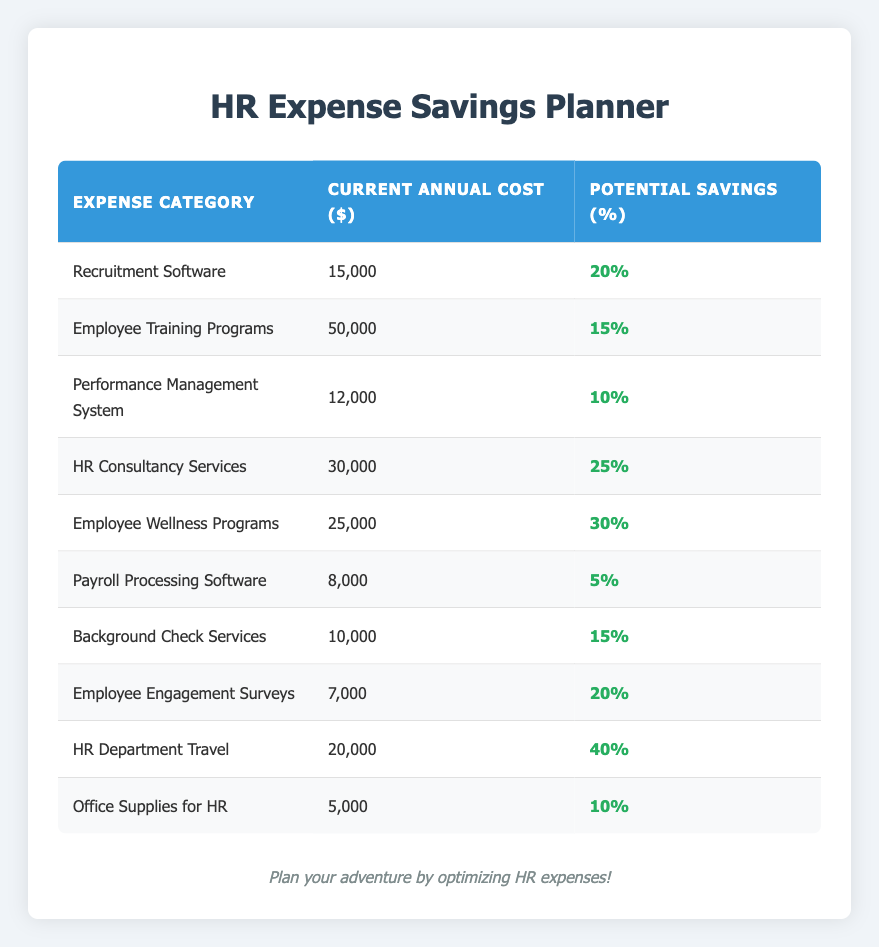What is the current annual cost of HR Consultancy Services? The table specifies that the current annual cost for HR Consultancy Services is listed under the "Current Annual Cost ($)" column. Upon checking, the value is 30,000.
Answer: 30,000 What percentage of savings can be achieved from Employee Training Programs? According to the table, the potential savings percentage for Employee Training Programs is indicated in the "Potential Savings (%)" column. It shows a potential saving of 15%.
Answer: 15% Which expense category has the highest potential savings percentage? To find the highest potential savings percentage, compare the values in the "Potential Savings (%)" column. The Employee Wellness Programs have the highest percentage at 30%.
Answer: Employee Wellness Programs If we sum the current annual costs of Recruitment Software and Background Check Services, what will the total be? First, find the current annual costs for each category: Recruitment Software is 15,000 and Background Check Services is 10,000. Adding these together gives 15,000 + 10,000 = 25,000.
Answer: 25,000 Is the potential savings percentage for Office Supplies for HR greater than 10%? The table lists the potential savings percentage for Office Supplies for HR as 10%. Since it is not greater than 10%, the answer is no.
Answer: No What is the total current annual cost for all listed expense categories? Add all the values listed under "Current Annual Cost ($)" together: 15,000 + 50,000 + 12,000 + 30,000 + 25,000 + 8,000 + 10,000 + 7,000 + 20,000 + 5,000 = 5,000 + 8,000 + 10,000 + 12,000 + 15,000 + 20,000 + 25,000 + 30,000 + 50,000 = 277,000.
Answer: 277,000 If we consider the HR Department Travel, what is the actual dollar amount saved if we achieve the potential savings percentage? The current annual cost for HR Department Travel is 20,000, with a potential savings of 40%. To calculate the savings, multiply 20,000 by 0.40, which equals 8,000.
Answer: 8,000 What is the average potential savings percentage of all categories listed in the table? First, we sum the potential savings percentages for all categories: 20% + 15% + 10% + 25% + 30% + 5% + 15% + 20% + 40% + 10% = 5 + 10 + 15 + 20 + 20 + 25 + 30 + 40 = 30 + 25 + 15 + 20 + 10 + 15 + 40 = 10 + 20 + 15 + 20 + 30 + 10 + 50 = 25 + 25 + 25 + 25 = 250. After finding the total of 250%, divide by the number of categories (10) for the average: 250 / 10 = 25%.
Answer: 25% 